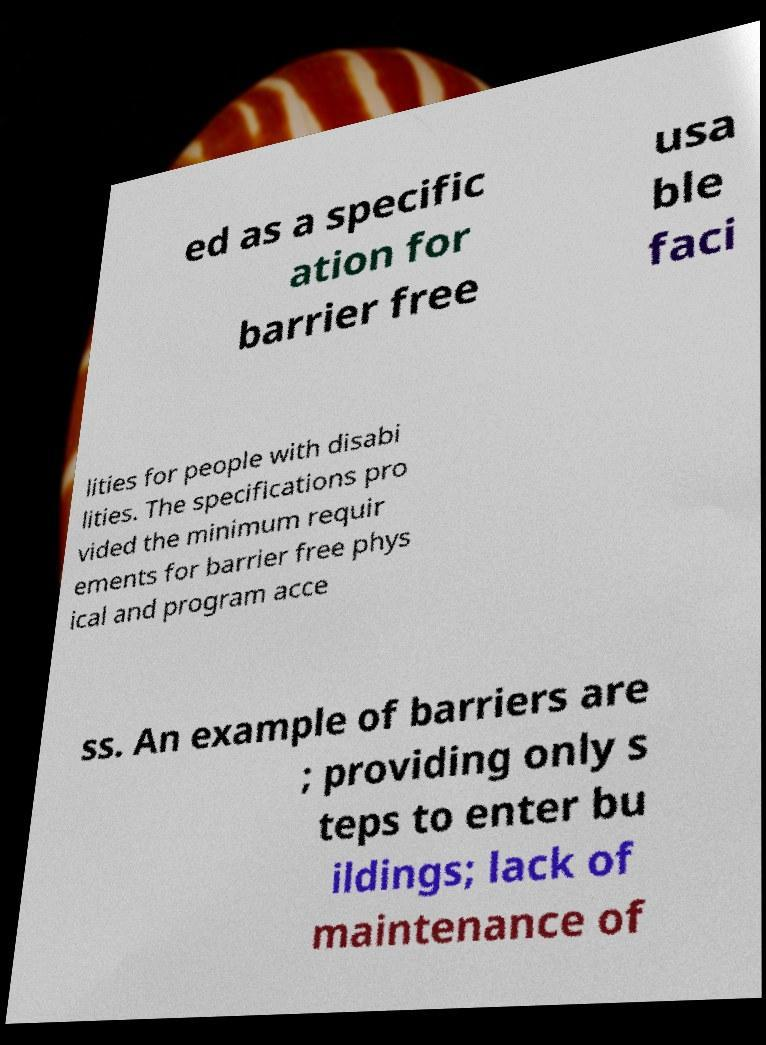Could you assist in decoding the text presented in this image and type it out clearly? ed as a specific ation for barrier free usa ble faci lities for people with disabi lities. The specifications pro vided the minimum requir ements for barrier free phys ical and program acce ss. An example of barriers are ; providing only s teps to enter bu ildings; lack of maintenance of 